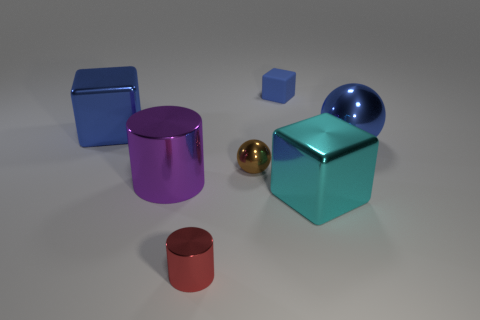Add 2 large blue shiny cubes. How many objects exist? 9 Subtract all cylinders. How many objects are left? 5 Subtract all yellow shiny things. Subtract all large blue metallic cubes. How many objects are left? 6 Add 6 small cylinders. How many small cylinders are left? 7 Add 4 tiny brown metal objects. How many tiny brown metal objects exist? 5 Subtract 0 gray spheres. How many objects are left? 7 